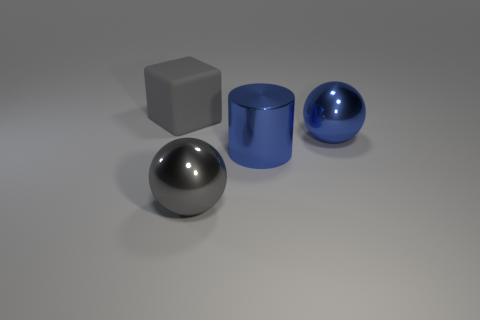Add 4 blue shiny cylinders. How many objects exist? 8 Subtract all cubes. How many objects are left? 3 Subtract all large gray matte cubes. Subtract all big red blocks. How many objects are left? 3 Add 1 blue things. How many blue things are left? 3 Add 3 blocks. How many blocks exist? 4 Subtract 0 green blocks. How many objects are left? 4 